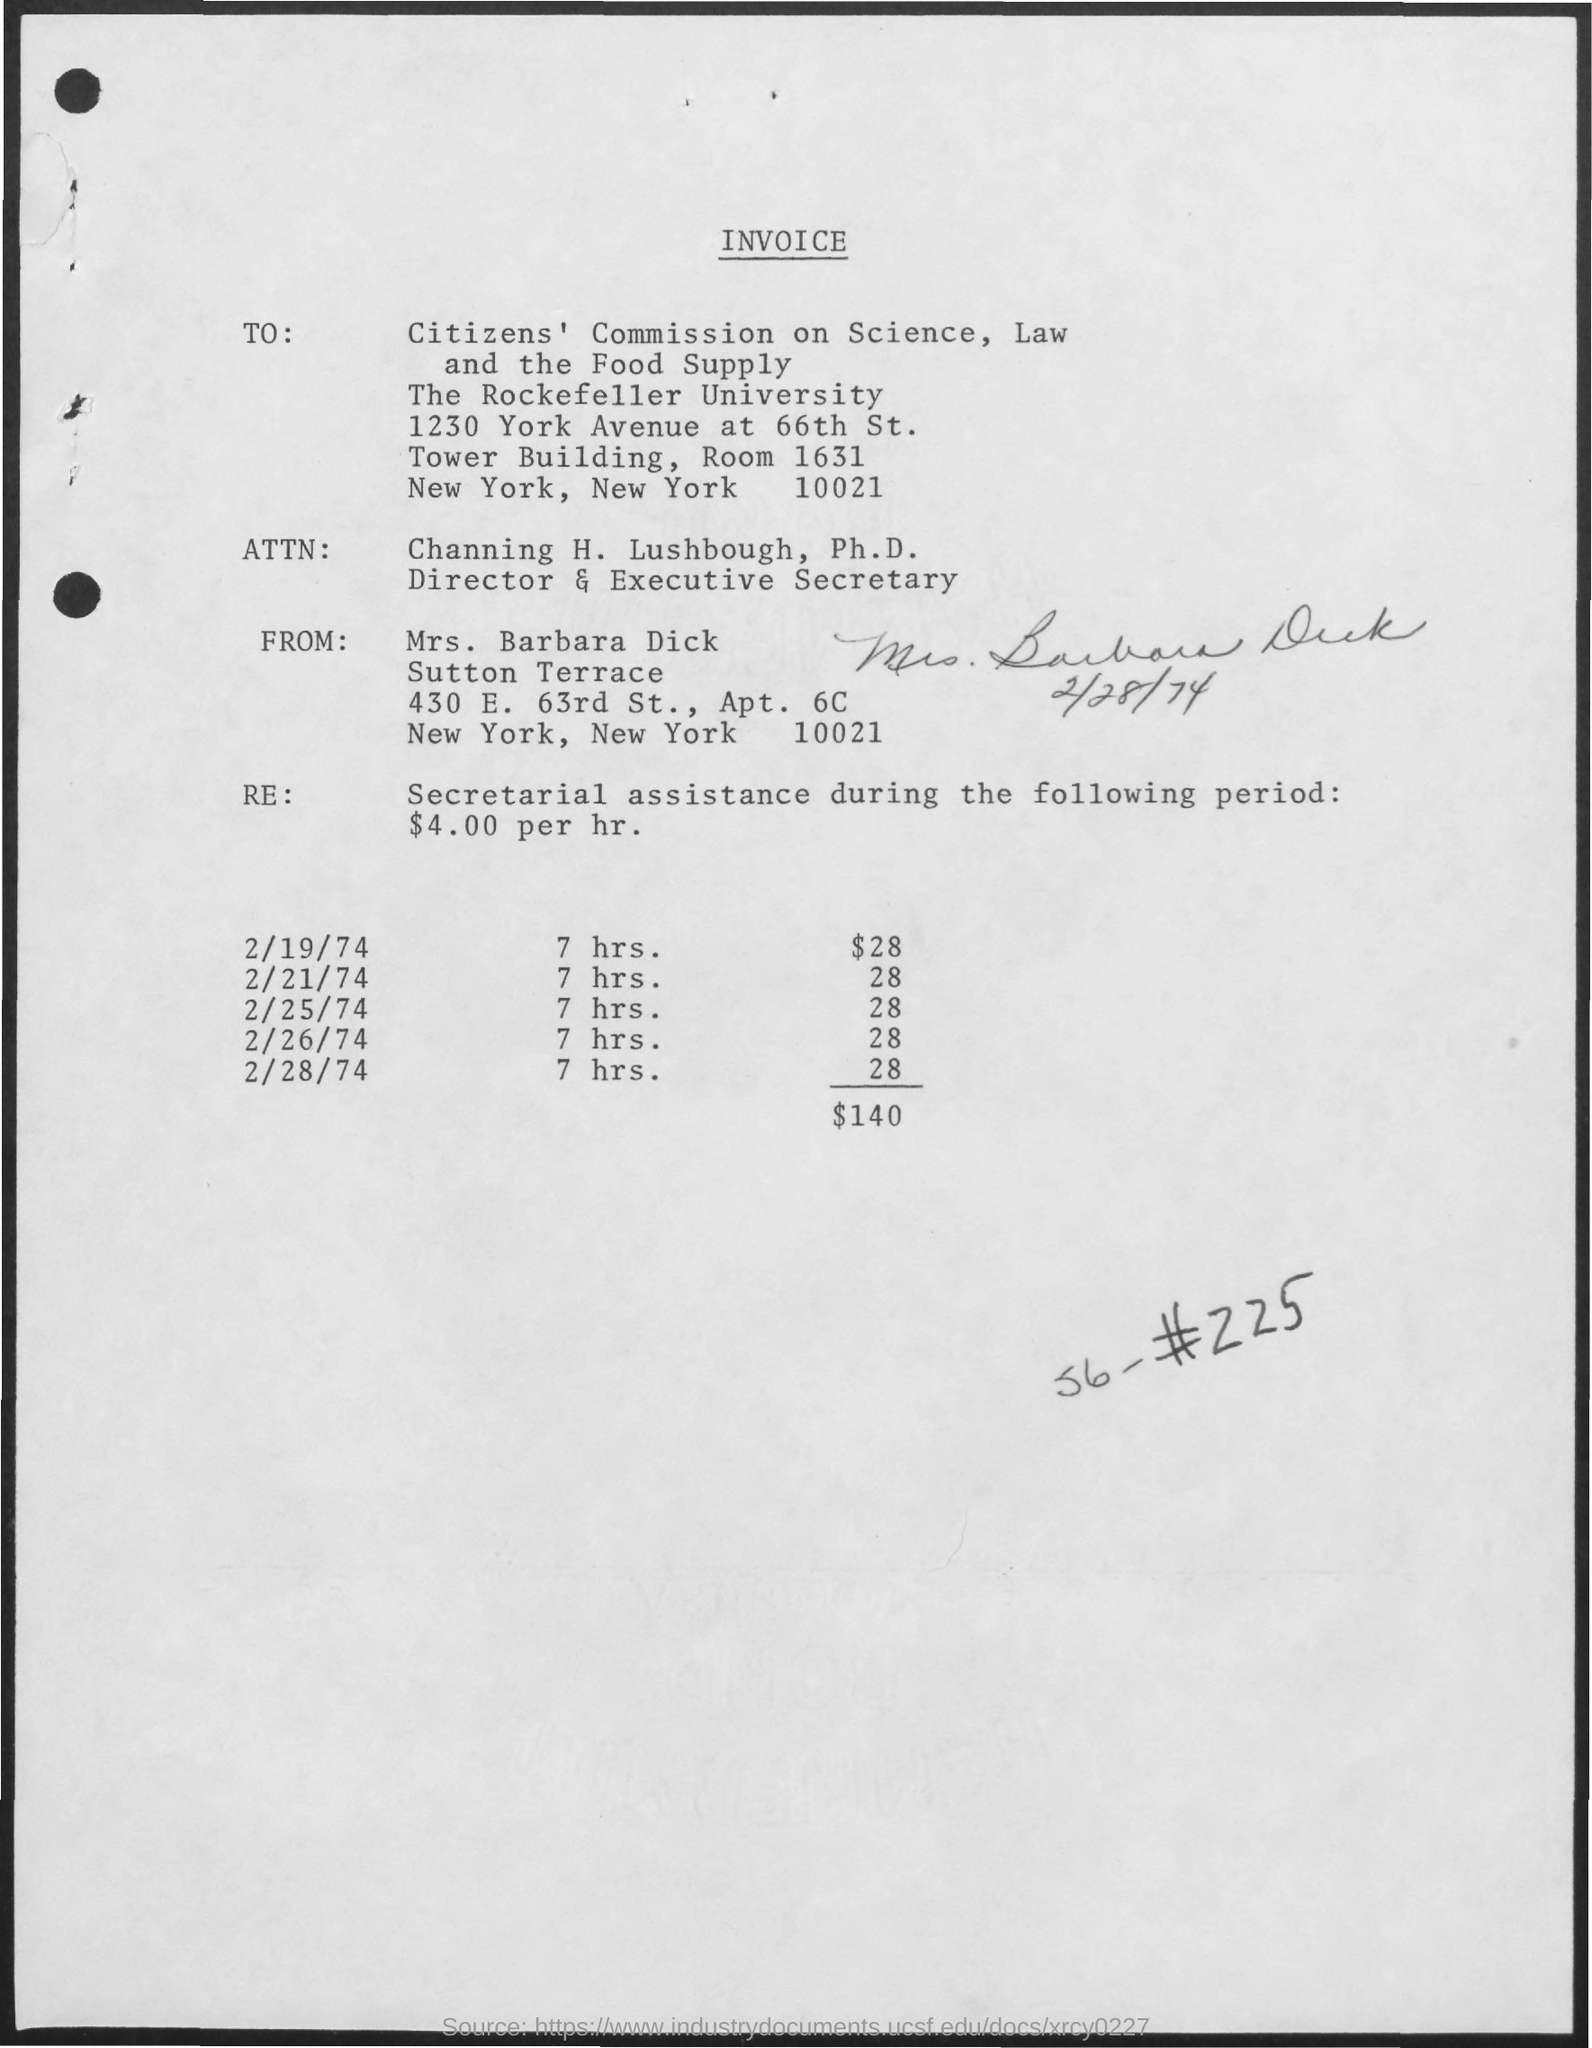What services did Mrs. Barbara Dick provide and what was her hourly rate? Mrs. Barbara Dick provided secretarial assistance at an hourly rate of $4.00 per hour during February 1974. She worked for a total of 28 hours, earning $140.  What organization received the invoice and to whose attention was it directed? The invoice was addressed to the Citizens' Commission on Science, Law, and the Food Supply at The Rockefeller University, and it was directed to Channing H. Lushbough, Ph.D., who is the Director & Executive Secretary. 